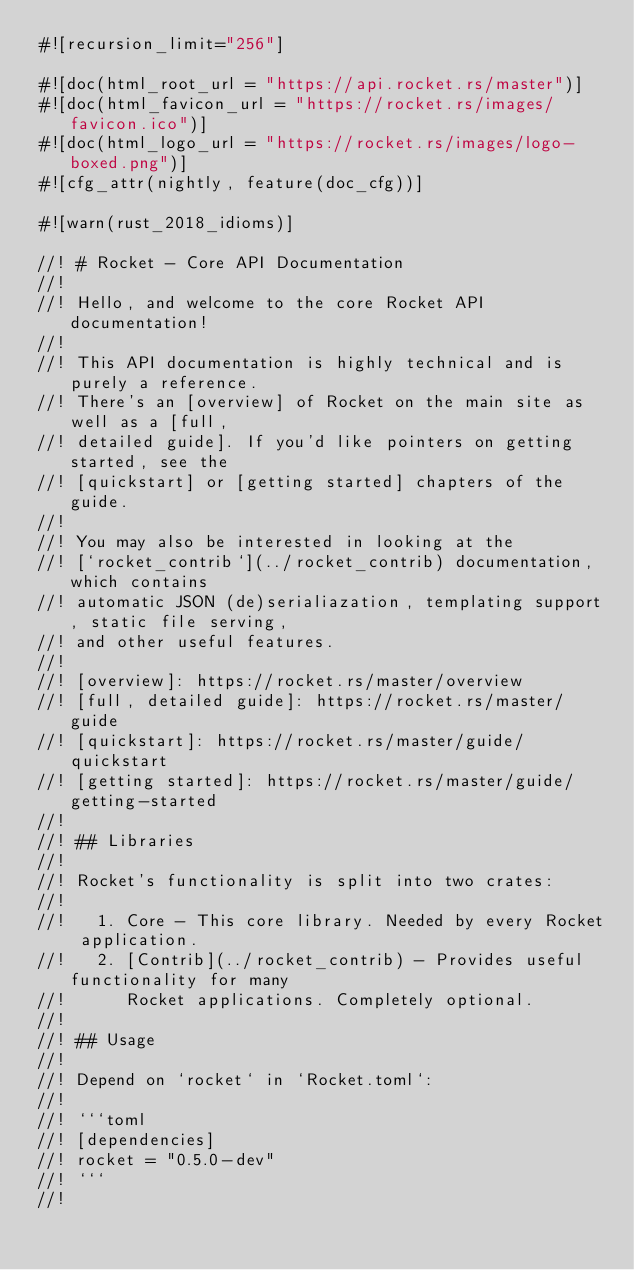Convert code to text. <code><loc_0><loc_0><loc_500><loc_500><_Rust_>#![recursion_limit="256"]

#![doc(html_root_url = "https://api.rocket.rs/master")]
#![doc(html_favicon_url = "https://rocket.rs/images/favicon.ico")]
#![doc(html_logo_url = "https://rocket.rs/images/logo-boxed.png")]
#![cfg_attr(nightly, feature(doc_cfg))]

#![warn(rust_2018_idioms)]

//! # Rocket - Core API Documentation
//!
//! Hello, and welcome to the core Rocket API documentation!
//!
//! This API documentation is highly technical and is purely a reference.
//! There's an [overview] of Rocket on the main site as well as a [full,
//! detailed guide]. If you'd like pointers on getting started, see the
//! [quickstart] or [getting started] chapters of the guide.
//!
//! You may also be interested in looking at the
//! [`rocket_contrib`](../rocket_contrib) documentation, which contains
//! automatic JSON (de)serialiazation, templating support, static file serving,
//! and other useful features.
//!
//! [overview]: https://rocket.rs/master/overview
//! [full, detailed guide]: https://rocket.rs/master/guide
//! [quickstart]: https://rocket.rs/master/guide/quickstart
//! [getting started]: https://rocket.rs/master/guide/getting-started
//!
//! ## Libraries
//!
//! Rocket's functionality is split into two crates:
//!
//!   1. Core - This core library. Needed by every Rocket application.
//!   2. [Contrib](../rocket_contrib) - Provides useful functionality for many
//!      Rocket applications. Completely optional.
//!
//! ## Usage
//!
//! Depend on `rocket` in `Rocket.toml`:
//!
//! ```toml
//! [dependencies]
//! rocket = "0.5.0-dev"
//! ```
//!</code> 